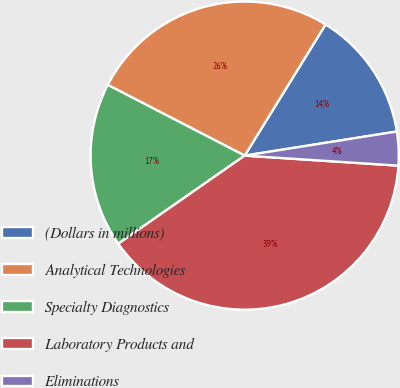Convert chart. <chart><loc_0><loc_0><loc_500><loc_500><pie_chart><fcel>(Dollars in millions)<fcel>Analytical Technologies<fcel>Specialty Diagnostics<fcel>Laboratory Products and<fcel>Eliminations<nl><fcel>13.7%<fcel>26.21%<fcel>17.28%<fcel>39.27%<fcel>3.54%<nl></chart> 